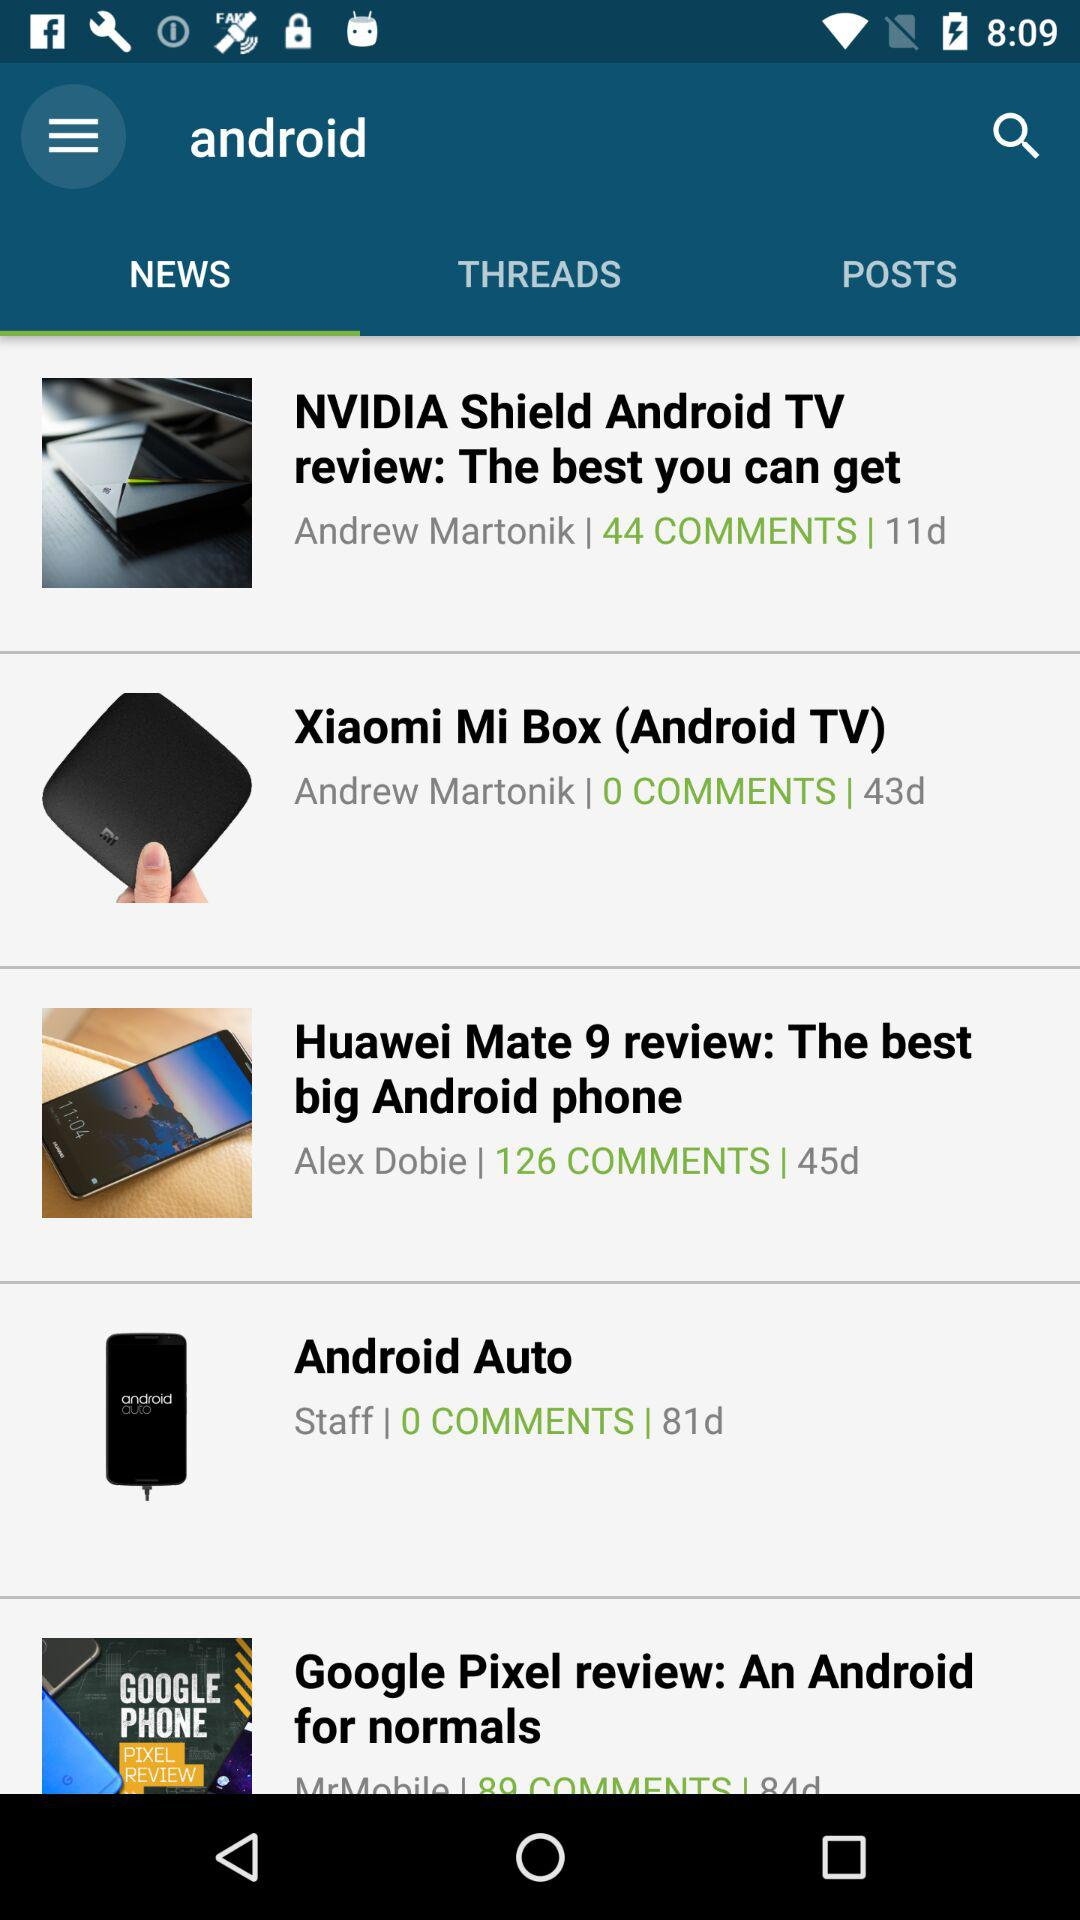Who is the author of "The best you can get"? The author is Andrew Martonik. 